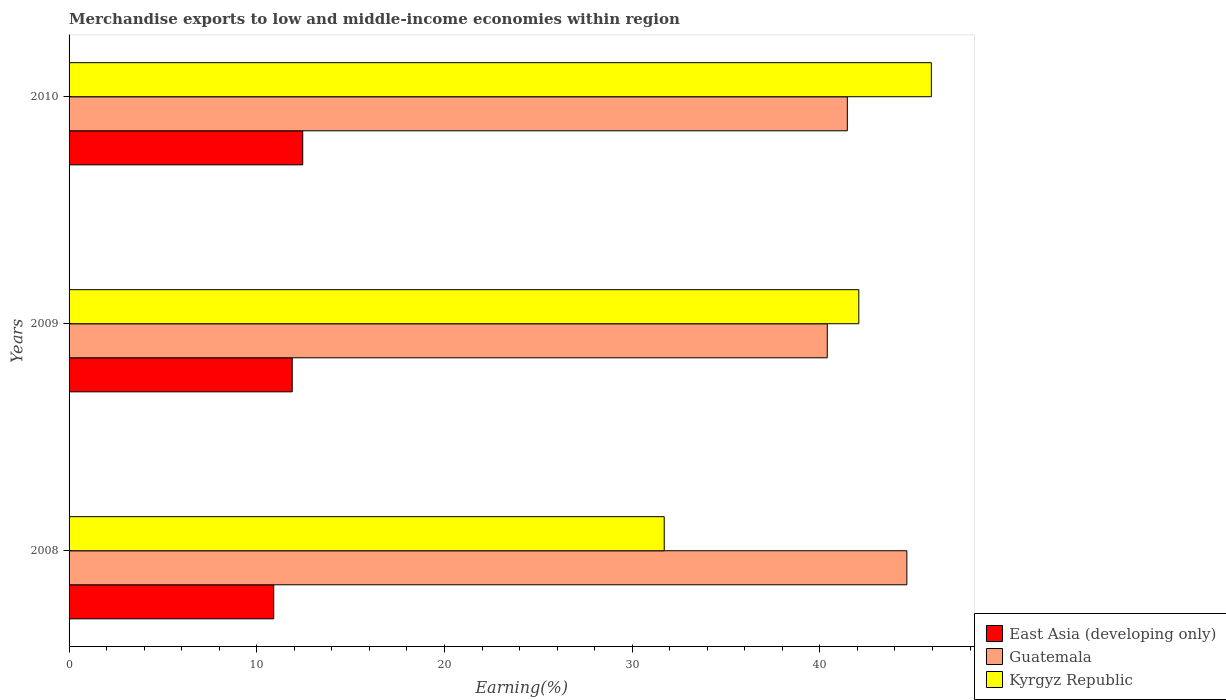How many different coloured bars are there?
Offer a very short reply. 3. How many bars are there on the 3rd tick from the top?
Keep it short and to the point. 3. How many bars are there on the 3rd tick from the bottom?
Offer a terse response. 3. What is the label of the 2nd group of bars from the top?
Provide a succinct answer. 2009. What is the percentage of amount earned from merchandise exports in East Asia (developing only) in 2010?
Give a very brief answer. 12.45. Across all years, what is the maximum percentage of amount earned from merchandise exports in East Asia (developing only)?
Your answer should be compact. 12.45. Across all years, what is the minimum percentage of amount earned from merchandise exports in Kyrgyz Republic?
Your answer should be compact. 31.71. In which year was the percentage of amount earned from merchandise exports in East Asia (developing only) maximum?
Provide a short and direct response. 2010. What is the total percentage of amount earned from merchandise exports in Kyrgyz Republic in the graph?
Your answer should be compact. 119.72. What is the difference between the percentage of amount earned from merchandise exports in East Asia (developing only) in 2008 and that in 2009?
Provide a succinct answer. -0.98. What is the difference between the percentage of amount earned from merchandise exports in Guatemala in 2009 and the percentage of amount earned from merchandise exports in East Asia (developing only) in 2008?
Give a very brief answer. 29.49. What is the average percentage of amount earned from merchandise exports in Kyrgyz Republic per year?
Provide a short and direct response. 39.91. In the year 2008, what is the difference between the percentage of amount earned from merchandise exports in East Asia (developing only) and percentage of amount earned from merchandise exports in Guatemala?
Give a very brief answer. -33.73. What is the ratio of the percentage of amount earned from merchandise exports in Kyrgyz Republic in 2008 to that in 2010?
Provide a succinct answer. 0.69. Is the percentage of amount earned from merchandise exports in East Asia (developing only) in 2008 less than that in 2010?
Offer a very short reply. Yes. Is the difference between the percentage of amount earned from merchandise exports in East Asia (developing only) in 2008 and 2009 greater than the difference between the percentage of amount earned from merchandise exports in Guatemala in 2008 and 2009?
Keep it short and to the point. No. What is the difference between the highest and the second highest percentage of amount earned from merchandise exports in East Asia (developing only)?
Make the answer very short. 0.56. What is the difference between the highest and the lowest percentage of amount earned from merchandise exports in Guatemala?
Keep it short and to the point. 4.24. What does the 1st bar from the top in 2010 represents?
Offer a very short reply. Kyrgyz Republic. What does the 2nd bar from the bottom in 2008 represents?
Provide a short and direct response. Guatemala. Is it the case that in every year, the sum of the percentage of amount earned from merchandise exports in Kyrgyz Republic and percentage of amount earned from merchandise exports in Guatemala is greater than the percentage of amount earned from merchandise exports in East Asia (developing only)?
Make the answer very short. Yes. How many bars are there?
Provide a short and direct response. 9. Are all the bars in the graph horizontal?
Keep it short and to the point. Yes. How many years are there in the graph?
Provide a succinct answer. 3. Are the values on the major ticks of X-axis written in scientific E-notation?
Your answer should be very brief. No. Does the graph contain any zero values?
Your answer should be compact. No. Does the graph contain grids?
Give a very brief answer. No. What is the title of the graph?
Ensure brevity in your answer.  Merchandise exports to low and middle-income economies within region. What is the label or title of the X-axis?
Offer a very short reply. Earning(%). What is the Earning(%) of East Asia (developing only) in 2008?
Provide a succinct answer. 10.9. What is the Earning(%) in Guatemala in 2008?
Offer a very short reply. 44.63. What is the Earning(%) in Kyrgyz Republic in 2008?
Keep it short and to the point. 31.71. What is the Earning(%) of East Asia (developing only) in 2009?
Your answer should be compact. 11.89. What is the Earning(%) in Guatemala in 2009?
Your answer should be very brief. 40.39. What is the Earning(%) in Kyrgyz Republic in 2009?
Provide a succinct answer. 42.07. What is the Earning(%) of East Asia (developing only) in 2010?
Provide a short and direct response. 12.45. What is the Earning(%) in Guatemala in 2010?
Your response must be concise. 41.46. What is the Earning(%) in Kyrgyz Republic in 2010?
Your answer should be compact. 45.94. Across all years, what is the maximum Earning(%) in East Asia (developing only)?
Give a very brief answer. 12.45. Across all years, what is the maximum Earning(%) of Guatemala?
Your answer should be compact. 44.63. Across all years, what is the maximum Earning(%) in Kyrgyz Republic?
Make the answer very short. 45.94. Across all years, what is the minimum Earning(%) of East Asia (developing only)?
Give a very brief answer. 10.9. Across all years, what is the minimum Earning(%) of Guatemala?
Your response must be concise. 40.39. Across all years, what is the minimum Earning(%) of Kyrgyz Republic?
Provide a succinct answer. 31.71. What is the total Earning(%) of East Asia (developing only) in the graph?
Provide a succinct answer. 35.24. What is the total Earning(%) of Guatemala in the graph?
Provide a short and direct response. 126.49. What is the total Earning(%) in Kyrgyz Republic in the graph?
Keep it short and to the point. 119.72. What is the difference between the Earning(%) in East Asia (developing only) in 2008 and that in 2009?
Give a very brief answer. -0.98. What is the difference between the Earning(%) of Guatemala in 2008 and that in 2009?
Your answer should be very brief. 4.24. What is the difference between the Earning(%) in Kyrgyz Republic in 2008 and that in 2009?
Keep it short and to the point. -10.37. What is the difference between the Earning(%) of East Asia (developing only) in 2008 and that in 2010?
Ensure brevity in your answer.  -1.54. What is the difference between the Earning(%) of Guatemala in 2008 and that in 2010?
Provide a succinct answer. 3.17. What is the difference between the Earning(%) in Kyrgyz Republic in 2008 and that in 2010?
Offer a terse response. -14.23. What is the difference between the Earning(%) of East Asia (developing only) in 2009 and that in 2010?
Your response must be concise. -0.56. What is the difference between the Earning(%) in Guatemala in 2009 and that in 2010?
Keep it short and to the point. -1.07. What is the difference between the Earning(%) of Kyrgyz Republic in 2009 and that in 2010?
Offer a very short reply. -3.87. What is the difference between the Earning(%) of East Asia (developing only) in 2008 and the Earning(%) of Guatemala in 2009?
Your answer should be compact. -29.49. What is the difference between the Earning(%) in East Asia (developing only) in 2008 and the Earning(%) in Kyrgyz Republic in 2009?
Offer a terse response. -31.17. What is the difference between the Earning(%) in Guatemala in 2008 and the Earning(%) in Kyrgyz Republic in 2009?
Ensure brevity in your answer.  2.56. What is the difference between the Earning(%) in East Asia (developing only) in 2008 and the Earning(%) in Guatemala in 2010?
Your response must be concise. -30.56. What is the difference between the Earning(%) of East Asia (developing only) in 2008 and the Earning(%) of Kyrgyz Republic in 2010?
Give a very brief answer. -35.03. What is the difference between the Earning(%) of Guatemala in 2008 and the Earning(%) of Kyrgyz Republic in 2010?
Ensure brevity in your answer.  -1.3. What is the difference between the Earning(%) in East Asia (developing only) in 2009 and the Earning(%) in Guatemala in 2010?
Offer a terse response. -29.57. What is the difference between the Earning(%) in East Asia (developing only) in 2009 and the Earning(%) in Kyrgyz Republic in 2010?
Offer a very short reply. -34.05. What is the difference between the Earning(%) in Guatemala in 2009 and the Earning(%) in Kyrgyz Republic in 2010?
Your answer should be compact. -5.55. What is the average Earning(%) of East Asia (developing only) per year?
Offer a very short reply. 11.75. What is the average Earning(%) in Guatemala per year?
Ensure brevity in your answer.  42.16. What is the average Earning(%) in Kyrgyz Republic per year?
Give a very brief answer. 39.91. In the year 2008, what is the difference between the Earning(%) of East Asia (developing only) and Earning(%) of Guatemala?
Provide a short and direct response. -33.73. In the year 2008, what is the difference between the Earning(%) of East Asia (developing only) and Earning(%) of Kyrgyz Republic?
Make the answer very short. -20.8. In the year 2008, what is the difference between the Earning(%) of Guatemala and Earning(%) of Kyrgyz Republic?
Offer a terse response. 12.93. In the year 2009, what is the difference between the Earning(%) of East Asia (developing only) and Earning(%) of Guatemala?
Your answer should be compact. -28.5. In the year 2009, what is the difference between the Earning(%) in East Asia (developing only) and Earning(%) in Kyrgyz Republic?
Ensure brevity in your answer.  -30.18. In the year 2009, what is the difference between the Earning(%) of Guatemala and Earning(%) of Kyrgyz Republic?
Your response must be concise. -1.68. In the year 2010, what is the difference between the Earning(%) of East Asia (developing only) and Earning(%) of Guatemala?
Provide a succinct answer. -29.01. In the year 2010, what is the difference between the Earning(%) of East Asia (developing only) and Earning(%) of Kyrgyz Republic?
Your response must be concise. -33.49. In the year 2010, what is the difference between the Earning(%) in Guatemala and Earning(%) in Kyrgyz Republic?
Your response must be concise. -4.48. What is the ratio of the Earning(%) of East Asia (developing only) in 2008 to that in 2009?
Provide a succinct answer. 0.92. What is the ratio of the Earning(%) in Guatemala in 2008 to that in 2009?
Give a very brief answer. 1.1. What is the ratio of the Earning(%) in Kyrgyz Republic in 2008 to that in 2009?
Offer a very short reply. 0.75. What is the ratio of the Earning(%) in East Asia (developing only) in 2008 to that in 2010?
Your answer should be compact. 0.88. What is the ratio of the Earning(%) in Guatemala in 2008 to that in 2010?
Provide a succinct answer. 1.08. What is the ratio of the Earning(%) of Kyrgyz Republic in 2008 to that in 2010?
Your answer should be compact. 0.69. What is the ratio of the Earning(%) of East Asia (developing only) in 2009 to that in 2010?
Ensure brevity in your answer.  0.95. What is the ratio of the Earning(%) in Guatemala in 2009 to that in 2010?
Provide a short and direct response. 0.97. What is the ratio of the Earning(%) in Kyrgyz Republic in 2009 to that in 2010?
Give a very brief answer. 0.92. What is the difference between the highest and the second highest Earning(%) in East Asia (developing only)?
Your response must be concise. 0.56. What is the difference between the highest and the second highest Earning(%) in Guatemala?
Make the answer very short. 3.17. What is the difference between the highest and the second highest Earning(%) of Kyrgyz Republic?
Your answer should be compact. 3.87. What is the difference between the highest and the lowest Earning(%) of East Asia (developing only)?
Your response must be concise. 1.54. What is the difference between the highest and the lowest Earning(%) in Guatemala?
Provide a succinct answer. 4.24. What is the difference between the highest and the lowest Earning(%) of Kyrgyz Republic?
Your response must be concise. 14.23. 